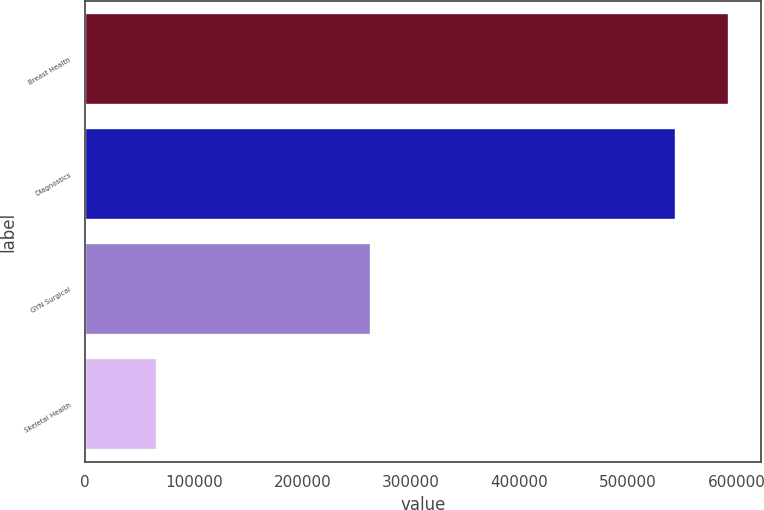<chart> <loc_0><loc_0><loc_500><loc_500><bar_chart><fcel>Breast Health<fcel>Diagnostics<fcel>GYN Surgical<fcel>Skeletal Health<nl><fcel>592790<fcel>544143<fcel>263187<fcel>66591<nl></chart> 